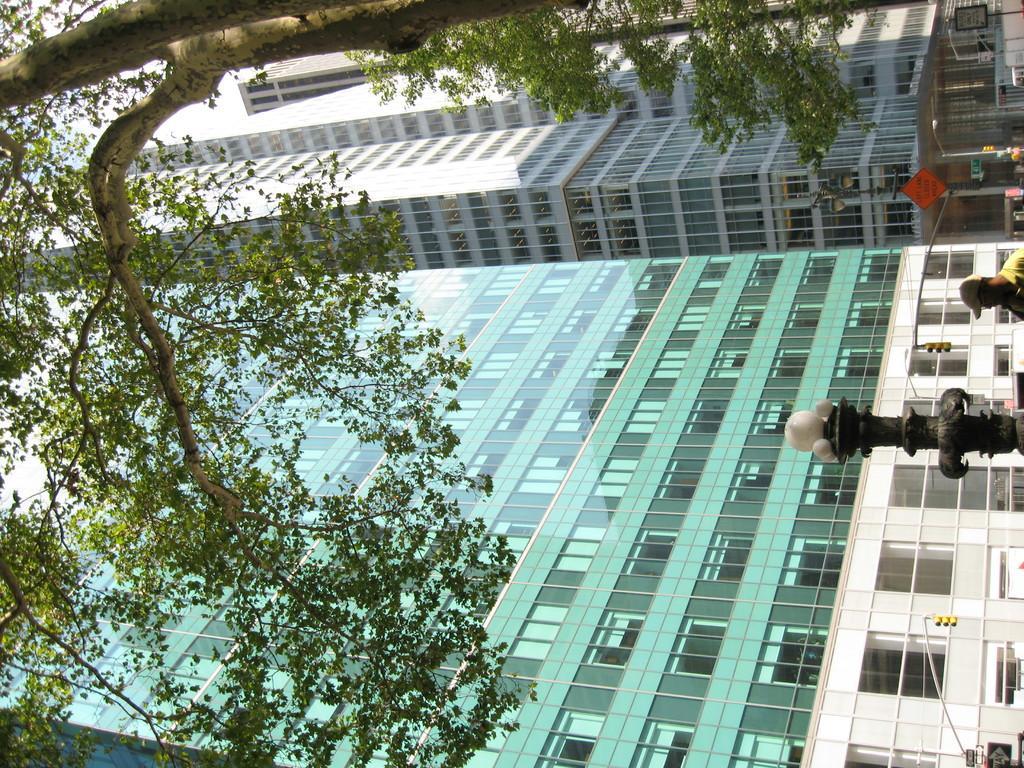What type of natural elements can be seen in the image? There are trees in the image. What type of man-made structures are visible in the image? There are buildings in the image. What type of street furniture can be seen in the image? There are light poles in the image. What is the group of people doing in the image? The group of people is on the road in the image. What time of day is the image likely taken? The image is likely taken during the day, as there is no indication of darkness or artificial lighting. What type of trousers is the grandmother wearing in the image? There is no grandmother or trousers present in the image. What type of furniture can be seen in the bedroom in the image? There is no bedroom or furniture present in the image. 